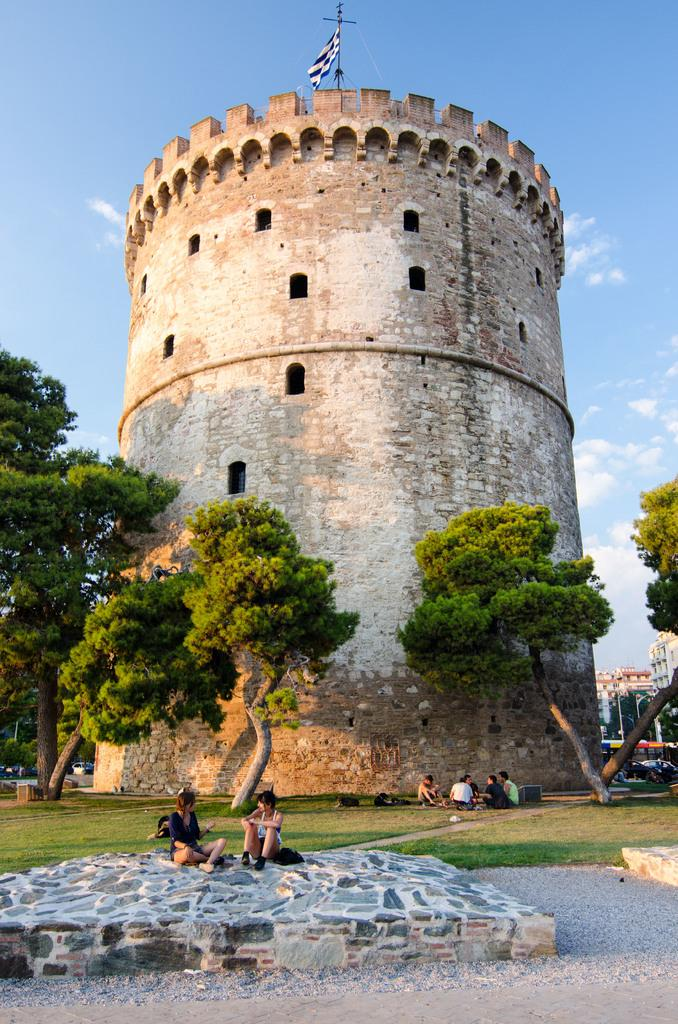How many people are in the image? There are few persons in the image. What type of natural environment is present in the image? There are trees and grass in the image, and there is a forest as well. What type of man-made structures can be seen in the image? There are vehicles, buildings, and a flag in the image. What is visible in the background of the image? The sky is visible in the background of the image, and there are clouds in the sky. What month is it in the image? The month cannot be determined from the image, as there is no information about the time of year. Can you see a nest in the image? There is no nest visible in the image. 